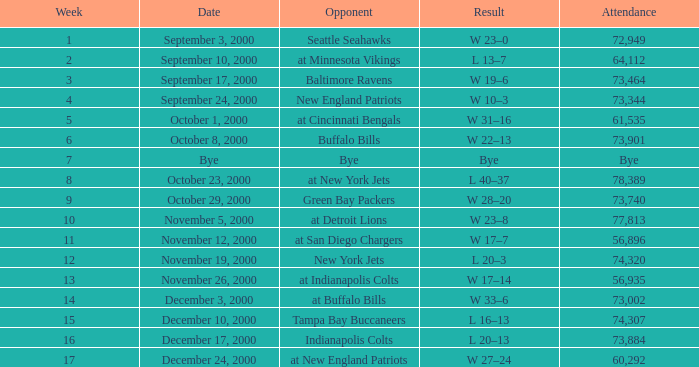What is the Attendance for a Week earlier than 16, and a Date of bye? Bye. 